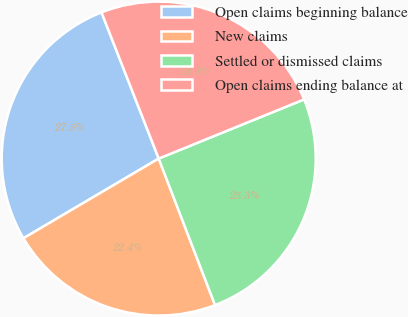Convert chart. <chart><loc_0><loc_0><loc_500><loc_500><pie_chart><fcel>Open claims beginning balance<fcel>New claims<fcel>Settled or dismissed claims<fcel>Open claims ending balance at<nl><fcel>27.54%<fcel>22.37%<fcel>25.31%<fcel>24.79%<nl></chart> 